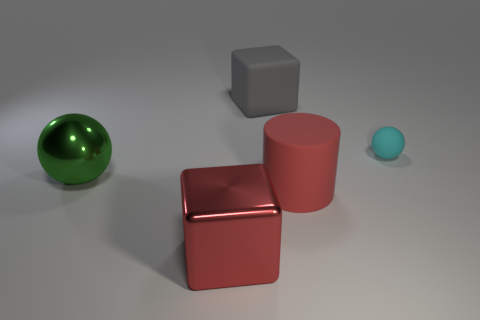There is a large thing that is the same color as the large cylinder; what is its shape?
Provide a short and direct response. Cube. Are any purple metal balls visible?
Provide a succinct answer. No. Is the shape of the large red thing that is to the right of the red shiny block the same as the object behind the tiny matte thing?
Ensure brevity in your answer.  No. What number of large objects are either matte balls or matte things?
Your answer should be compact. 2. What shape is the large gray object that is made of the same material as the cyan sphere?
Your answer should be compact. Cube. Does the small object have the same shape as the green thing?
Your response must be concise. Yes. The shiny sphere is what color?
Ensure brevity in your answer.  Green. How many objects are tiny green metal objects or matte objects?
Provide a short and direct response. 3. Is the number of large green balls that are to the right of the big green object less than the number of large brown shiny cylinders?
Offer a very short reply. No. Is the number of gray rubber objects that are left of the big red matte cylinder greater than the number of gray matte blocks behind the gray matte object?
Make the answer very short. Yes. 